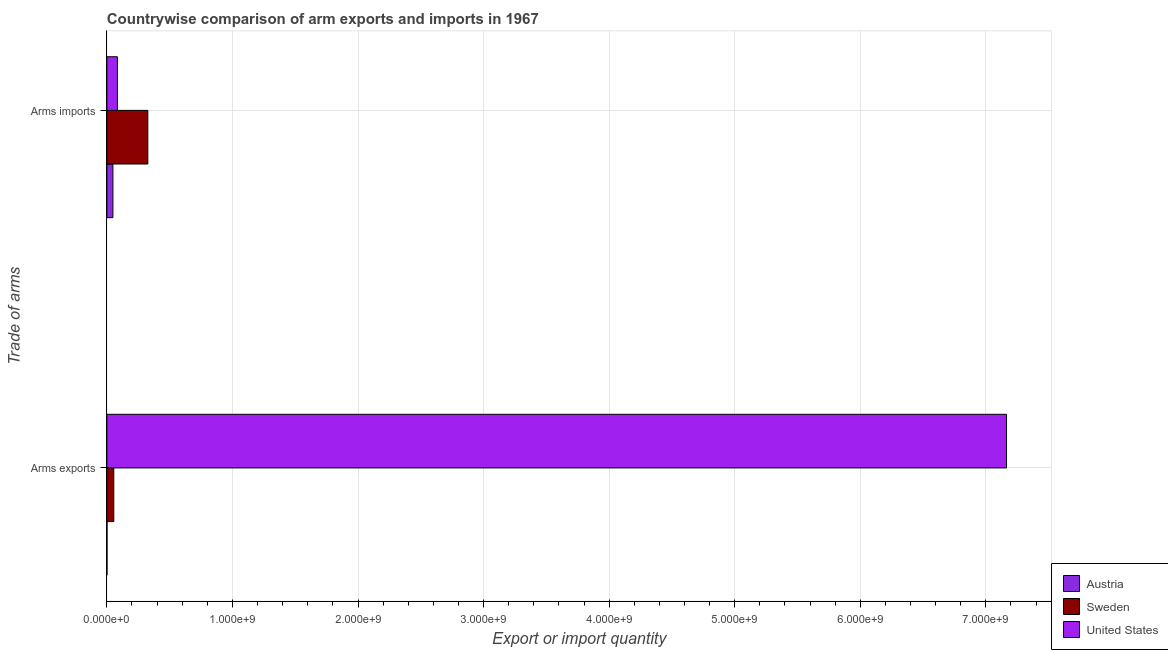How many groups of bars are there?
Your response must be concise. 2. Are the number of bars per tick equal to the number of legend labels?
Your answer should be very brief. Yes. How many bars are there on the 2nd tick from the bottom?
Make the answer very short. 3. What is the label of the 2nd group of bars from the top?
Give a very brief answer. Arms exports. What is the arms imports in United States?
Provide a short and direct response. 8.40e+07. Across all countries, what is the maximum arms exports?
Keep it short and to the point. 7.16e+09. Across all countries, what is the minimum arms exports?
Your answer should be compact. 1.00e+06. In which country was the arms exports maximum?
Give a very brief answer. United States. What is the total arms exports in the graph?
Provide a succinct answer. 7.22e+09. What is the difference between the arms exports in Sweden and that in United States?
Provide a succinct answer. -7.11e+09. What is the difference between the arms imports in Sweden and the arms exports in Austria?
Keep it short and to the point. 3.25e+08. What is the average arms exports per country?
Keep it short and to the point. 2.41e+09. What is the difference between the arms imports and arms exports in Sweden?
Offer a terse response. 2.71e+08. In how many countries, is the arms imports greater than 3200000000 ?
Give a very brief answer. 0. What is the ratio of the arms imports in United States to that in Sweden?
Provide a short and direct response. 0.26. Is the arms imports in Sweden less than that in United States?
Your response must be concise. No. In how many countries, is the arms exports greater than the average arms exports taken over all countries?
Make the answer very short. 1. What does the 2nd bar from the top in Arms imports represents?
Make the answer very short. Sweden. How many bars are there?
Keep it short and to the point. 6. How many countries are there in the graph?
Keep it short and to the point. 3. What is the difference between two consecutive major ticks on the X-axis?
Ensure brevity in your answer.  1.00e+09. Does the graph contain any zero values?
Your response must be concise. No. How many legend labels are there?
Provide a succinct answer. 3. How are the legend labels stacked?
Provide a short and direct response. Vertical. What is the title of the graph?
Your response must be concise. Countrywise comparison of arm exports and imports in 1967. Does "Uruguay" appear as one of the legend labels in the graph?
Your response must be concise. No. What is the label or title of the X-axis?
Ensure brevity in your answer.  Export or import quantity. What is the label or title of the Y-axis?
Provide a short and direct response. Trade of arms. What is the Export or import quantity of Sweden in Arms exports?
Ensure brevity in your answer.  5.50e+07. What is the Export or import quantity in United States in Arms exports?
Ensure brevity in your answer.  7.16e+09. What is the Export or import quantity of Austria in Arms imports?
Offer a very short reply. 4.80e+07. What is the Export or import quantity of Sweden in Arms imports?
Make the answer very short. 3.26e+08. What is the Export or import quantity of United States in Arms imports?
Your answer should be very brief. 8.40e+07. Across all Trade of arms, what is the maximum Export or import quantity in Austria?
Keep it short and to the point. 4.80e+07. Across all Trade of arms, what is the maximum Export or import quantity in Sweden?
Keep it short and to the point. 3.26e+08. Across all Trade of arms, what is the maximum Export or import quantity of United States?
Your answer should be very brief. 7.16e+09. Across all Trade of arms, what is the minimum Export or import quantity of Sweden?
Provide a short and direct response. 5.50e+07. Across all Trade of arms, what is the minimum Export or import quantity in United States?
Your answer should be compact. 8.40e+07. What is the total Export or import quantity of Austria in the graph?
Offer a terse response. 4.90e+07. What is the total Export or import quantity of Sweden in the graph?
Provide a succinct answer. 3.81e+08. What is the total Export or import quantity in United States in the graph?
Make the answer very short. 7.25e+09. What is the difference between the Export or import quantity of Austria in Arms exports and that in Arms imports?
Your answer should be very brief. -4.70e+07. What is the difference between the Export or import quantity in Sweden in Arms exports and that in Arms imports?
Give a very brief answer. -2.71e+08. What is the difference between the Export or import quantity of United States in Arms exports and that in Arms imports?
Your response must be concise. 7.08e+09. What is the difference between the Export or import quantity in Austria in Arms exports and the Export or import quantity in Sweden in Arms imports?
Ensure brevity in your answer.  -3.25e+08. What is the difference between the Export or import quantity in Austria in Arms exports and the Export or import quantity in United States in Arms imports?
Provide a succinct answer. -8.30e+07. What is the difference between the Export or import quantity of Sweden in Arms exports and the Export or import quantity of United States in Arms imports?
Your answer should be very brief. -2.90e+07. What is the average Export or import quantity in Austria per Trade of arms?
Ensure brevity in your answer.  2.45e+07. What is the average Export or import quantity in Sweden per Trade of arms?
Make the answer very short. 1.90e+08. What is the average Export or import quantity of United States per Trade of arms?
Ensure brevity in your answer.  3.62e+09. What is the difference between the Export or import quantity in Austria and Export or import quantity in Sweden in Arms exports?
Give a very brief answer. -5.40e+07. What is the difference between the Export or import quantity in Austria and Export or import quantity in United States in Arms exports?
Your response must be concise. -7.16e+09. What is the difference between the Export or import quantity in Sweden and Export or import quantity in United States in Arms exports?
Offer a very short reply. -7.11e+09. What is the difference between the Export or import quantity in Austria and Export or import quantity in Sweden in Arms imports?
Provide a succinct answer. -2.78e+08. What is the difference between the Export or import quantity in Austria and Export or import quantity in United States in Arms imports?
Offer a terse response. -3.60e+07. What is the difference between the Export or import quantity of Sweden and Export or import quantity of United States in Arms imports?
Ensure brevity in your answer.  2.42e+08. What is the ratio of the Export or import quantity in Austria in Arms exports to that in Arms imports?
Ensure brevity in your answer.  0.02. What is the ratio of the Export or import quantity of Sweden in Arms exports to that in Arms imports?
Ensure brevity in your answer.  0.17. What is the ratio of the Export or import quantity in United States in Arms exports to that in Arms imports?
Ensure brevity in your answer.  85.3. What is the difference between the highest and the second highest Export or import quantity of Austria?
Your answer should be very brief. 4.70e+07. What is the difference between the highest and the second highest Export or import quantity in Sweden?
Your response must be concise. 2.71e+08. What is the difference between the highest and the second highest Export or import quantity of United States?
Keep it short and to the point. 7.08e+09. What is the difference between the highest and the lowest Export or import quantity in Austria?
Provide a succinct answer. 4.70e+07. What is the difference between the highest and the lowest Export or import quantity in Sweden?
Offer a very short reply. 2.71e+08. What is the difference between the highest and the lowest Export or import quantity in United States?
Make the answer very short. 7.08e+09. 